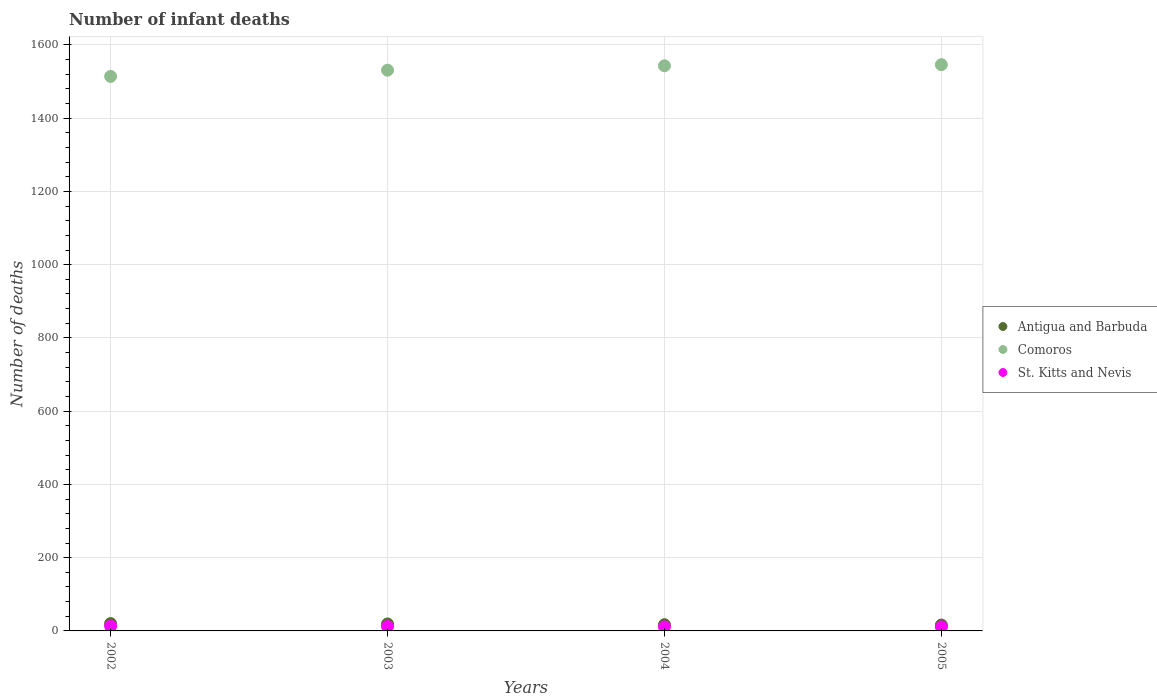Across all years, what is the maximum number of infant deaths in Comoros?
Keep it short and to the point. 1546. Across all years, what is the minimum number of infant deaths in Antigua and Barbuda?
Provide a succinct answer. 16. What is the difference between the number of infant deaths in Comoros in 2002 and that in 2005?
Offer a terse response. -32. What is the difference between the number of infant deaths in St. Kitts and Nevis in 2004 and the number of infant deaths in Antigua and Barbuda in 2002?
Your answer should be compact. -9. What is the average number of infant deaths in St. Kitts and Nevis per year?
Offer a terse response. 11.75. In the year 2003, what is the difference between the number of infant deaths in Comoros and number of infant deaths in St. Kitts and Nevis?
Offer a terse response. 1519. What is the ratio of the number of infant deaths in Antigua and Barbuda in 2004 to that in 2005?
Your answer should be compact. 1.06. Is the difference between the number of infant deaths in Comoros in 2002 and 2003 greater than the difference between the number of infant deaths in St. Kitts and Nevis in 2002 and 2003?
Ensure brevity in your answer.  No. What is the difference between the highest and the lowest number of infant deaths in St. Kitts and Nevis?
Offer a very short reply. 2. Is the sum of the number of infant deaths in St. Kitts and Nevis in 2002 and 2005 greater than the maximum number of infant deaths in Antigua and Barbuda across all years?
Your answer should be very brief. Yes. Is it the case that in every year, the sum of the number of infant deaths in Antigua and Barbuda and number of infant deaths in St. Kitts and Nevis  is greater than the number of infant deaths in Comoros?
Keep it short and to the point. No. Is the number of infant deaths in Comoros strictly less than the number of infant deaths in St. Kitts and Nevis over the years?
Offer a very short reply. No. How many dotlines are there?
Offer a terse response. 3. How many years are there in the graph?
Provide a succinct answer. 4. What is the difference between two consecutive major ticks on the Y-axis?
Make the answer very short. 200. Does the graph contain any zero values?
Provide a succinct answer. No. How are the legend labels stacked?
Your answer should be very brief. Vertical. What is the title of the graph?
Keep it short and to the point. Number of infant deaths. What is the label or title of the Y-axis?
Give a very brief answer. Number of deaths. What is the Number of deaths in Comoros in 2002?
Give a very brief answer. 1514. What is the Number of deaths of St. Kitts and Nevis in 2002?
Give a very brief answer. 13. What is the Number of deaths in Comoros in 2003?
Provide a succinct answer. 1531. What is the Number of deaths in Comoros in 2004?
Offer a terse response. 1543. What is the Number of deaths in Comoros in 2005?
Offer a very short reply. 1546. Across all years, what is the maximum Number of deaths of Antigua and Barbuda?
Make the answer very short. 20. Across all years, what is the maximum Number of deaths of Comoros?
Ensure brevity in your answer.  1546. Across all years, what is the maximum Number of deaths in St. Kitts and Nevis?
Your answer should be very brief. 13. Across all years, what is the minimum Number of deaths of Comoros?
Provide a short and direct response. 1514. What is the total Number of deaths of Comoros in the graph?
Ensure brevity in your answer.  6134. What is the difference between the Number of deaths of Comoros in 2002 and that in 2003?
Your answer should be very brief. -17. What is the difference between the Number of deaths of St. Kitts and Nevis in 2002 and that in 2004?
Keep it short and to the point. 2. What is the difference between the Number of deaths in Antigua and Barbuda in 2002 and that in 2005?
Your answer should be compact. 4. What is the difference between the Number of deaths in Comoros in 2002 and that in 2005?
Offer a very short reply. -32. What is the difference between the Number of deaths of Antigua and Barbuda in 2003 and that in 2004?
Offer a very short reply. 2. What is the difference between the Number of deaths in Comoros in 2003 and that in 2004?
Your answer should be compact. -12. What is the difference between the Number of deaths in St. Kitts and Nevis in 2003 and that in 2004?
Ensure brevity in your answer.  1. What is the difference between the Number of deaths of St. Kitts and Nevis in 2003 and that in 2005?
Make the answer very short. 1. What is the difference between the Number of deaths in Antigua and Barbuda in 2004 and that in 2005?
Offer a terse response. 1. What is the difference between the Number of deaths of St. Kitts and Nevis in 2004 and that in 2005?
Ensure brevity in your answer.  0. What is the difference between the Number of deaths in Antigua and Barbuda in 2002 and the Number of deaths in Comoros in 2003?
Your answer should be very brief. -1511. What is the difference between the Number of deaths of Antigua and Barbuda in 2002 and the Number of deaths of St. Kitts and Nevis in 2003?
Your response must be concise. 8. What is the difference between the Number of deaths in Comoros in 2002 and the Number of deaths in St. Kitts and Nevis in 2003?
Offer a very short reply. 1502. What is the difference between the Number of deaths of Antigua and Barbuda in 2002 and the Number of deaths of Comoros in 2004?
Offer a very short reply. -1523. What is the difference between the Number of deaths of Antigua and Barbuda in 2002 and the Number of deaths of St. Kitts and Nevis in 2004?
Give a very brief answer. 9. What is the difference between the Number of deaths in Comoros in 2002 and the Number of deaths in St. Kitts and Nevis in 2004?
Ensure brevity in your answer.  1503. What is the difference between the Number of deaths of Antigua and Barbuda in 2002 and the Number of deaths of Comoros in 2005?
Your answer should be very brief. -1526. What is the difference between the Number of deaths in Comoros in 2002 and the Number of deaths in St. Kitts and Nevis in 2005?
Provide a short and direct response. 1503. What is the difference between the Number of deaths in Antigua and Barbuda in 2003 and the Number of deaths in Comoros in 2004?
Give a very brief answer. -1524. What is the difference between the Number of deaths of Antigua and Barbuda in 2003 and the Number of deaths of St. Kitts and Nevis in 2004?
Your answer should be compact. 8. What is the difference between the Number of deaths of Comoros in 2003 and the Number of deaths of St. Kitts and Nevis in 2004?
Your answer should be very brief. 1520. What is the difference between the Number of deaths of Antigua and Barbuda in 2003 and the Number of deaths of Comoros in 2005?
Your response must be concise. -1527. What is the difference between the Number of deaths of Antigua and Barbuda in 2003 and the Number of deaths of St. Kitts and Nevis in 2005?
Your response must be concise. 8. What is the difference between the Number of deaths in Comoros in 2003 and the Number of deaths in St. Kitts and Nevis in 2005?
Provide a short and direct response. 1520. What is the difference between the Number of deaths of Antigua and Barbuda in 2004 and the Number of deaths of Comoros in 2005?
Your answer should be compact. -1529. What is the difference between the Number of deaths in Antigua and Barbuda in 2004 and the Number of deaths in St. Kitts and Nevis in 2005?
Provide a short and direct response. 6. What is the difference between the Number of deaths of Comoros in 2004 and the Number of deaths of St. Kitts and Nevis in 2005?
Keep it short and to the point. 1532. What is the average Number of deaths of Antigua and Barbuda per year?
Provide a succinct answer. 18. What is the average Number of deaths of Comoros per year?
Offer a terse response. 1533.5. What is the average Number of deaths of St. Kitts and Nevis per year?
Provide a short and direct response. 11.75. In the year 2002, what is the difference between the Number of deaths of Antigua and Barbuda and Number of deaths of Comoros?
Make the answer very short. -1494. In the year 2002, what is the difference between the Number of deaths in Comoros and Number of deaths in St. Kitts and Nevis?
Keep it short and to the point. 1501. In the year 2003, what is the difference between the Number of deaths in Antigua and Barbuda and Number of deaths in Comoros?
Keep it short and to the point. -1512. In the year 2003, what is the difference between the Number of deaths of Comoros and Number of deaths of St. Kitts and Nevis?
Provide a succinct answer. 1519. In the year 2004, what is the difference between the Number of deaths of Antigua and Barbuda and Number of deaths of Comoros?
Provide a succinct answer. -1526. In the year 2004, what is the difference between the Number of deaths of Antigua and Barbuda and Number of deaths of St. Kitts and Nevis?
Your response must be concise. 6. In the year 2004, what is the difference between the Number of deaths in Comoros and Number of deaths in St. Kitts and Nevis?
Offer a terse response. 1532. In the year 2005, what is the difference between the Number of deaths in Antigua and Barbuda and Number of deaths in Comoros?
Offer a terse response. -1530. In the year 2005, what is the difference between the Number of deaths in Comoros and Number of deaths in St. Kitts and Nevis?
Offer a very short reply. 1535. What is the ratio of the Number of deaths in Antigua and Barbuda in 2002 to that in 2003?
Ensure brevity in your answer.  1.05. What is the ratio of the Number of deaths of Comoros in 2002 to that in 2003?
Your answer should be compact. 0.99. What is the ratio of the Number of deaths in Antigua and Barbuda in 2002 to that in 2004?
Provide a succinct answer. 1.18. What is the ratio of the Number of deaths of Comoros in 2002 to that in 2004?
Offer a terse response. 0.98. What is the ratio of the Number of deaths in St. Kitts and Nevis in 2002 to that in 2004?
Offer a very short reply. 1.18. What is the ratio of the Number of deaths of Comoros in 2002 to that in 2005?
Your response must be concise. 0.98. What is the ratio of the Number of deaths of St. Kitts and Nevis in 2002 to that in 2005?
Your response must be concise. 1.18. What is the ratio of the Number of deaths of Antigua and Barbuda in 2003 to that in 2004?
Your response must be concise. 1.12. What is the ratio of the Number of deaths of St. Kitts and Nevis in 2003 to that in 2004?
Your response must be concise. 1.09. What is the ratio of the Number of deaths in Antigua and Barbuda in 2003 to that in 2005?
Your answer should be very brief. 1.19. What is the ratio of the Number of deaths of Comoros in 2003 to that in 2005?
Provide a succinct answer. 0.99. What is the ratio of the Number of deaths of Antigua and Barbuda in 2004 to that in 2005?
Your answer should be compact. 1.06. What is the ratio of the Number of deaths in St. Kitts and Nevis in 2004 to that in 2005?
Your response must be concise. 1. What is the difference between the highest and the second highest Number of deaths in Antigua and Barbuda?
Ensure brevity in your answer.  1. What is the difference between the highest and the second highest Number of deaths of St. Kitts and Nevis?
Offer a terse response. 1. What is the difference between the highest and the lowest Number of deaths in Antigua and Barbuda?
Keep it short and to the point. 4. 